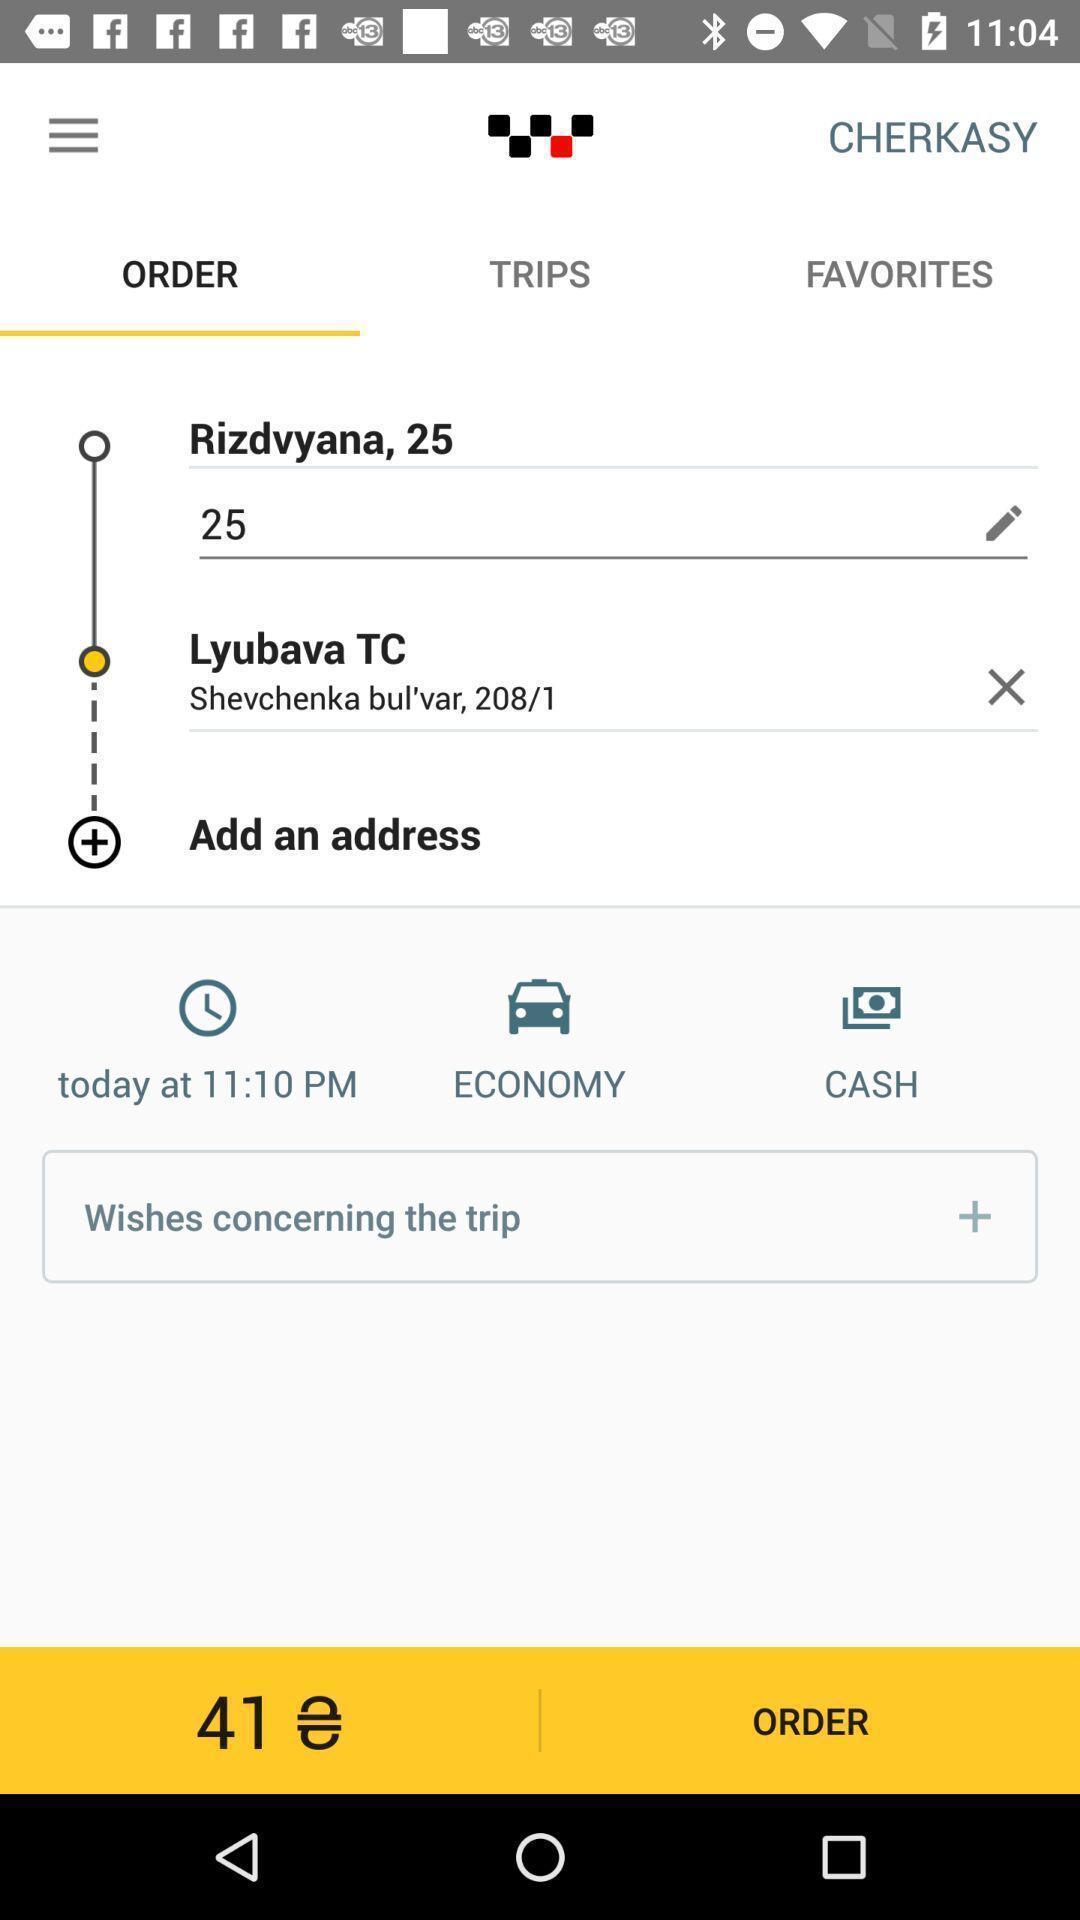What is the overall content of this screenshot? Travel ticket booking app with address filling tabs. 